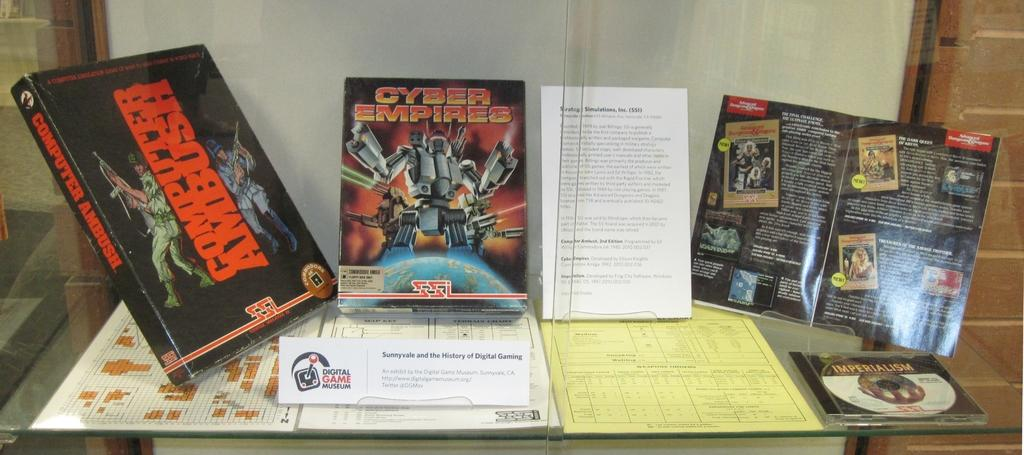Provide a one-sentence caption for the provided image. A book titled Computer Ambush set up to the left of some other books. 